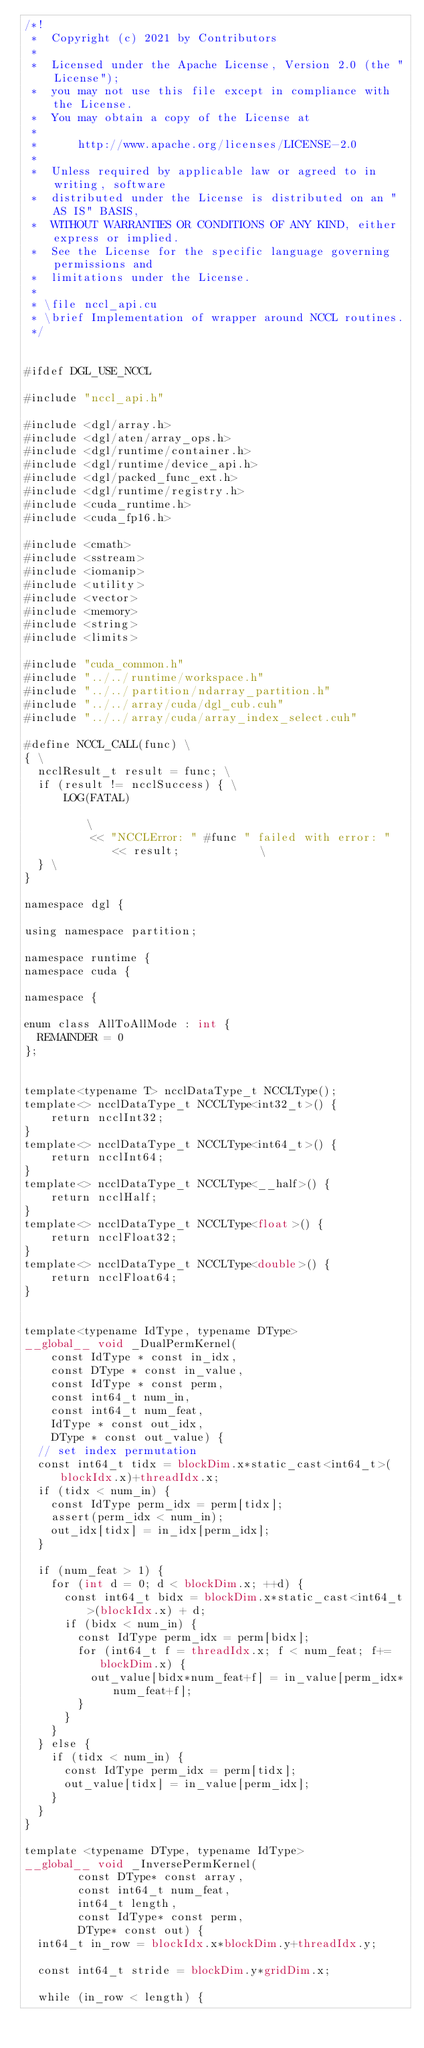Convert code to text. <code><loc_0><loc_0><loc_500><loc_500><_Cuda_>/*!
 *  Copyright (c) 2021 by Contributors
 *
 *  Licensed under the Apache License, Version 2.0 (the "License");
 *  you may not use this file except in compliance with the License.
 *  You may obtain a copy of the License at
 *
 *      http://www.apache.org/licenses/LICENSE-2.0
 *
 *  Unless required by applicable law or agreed to in writing, software
 *  distributed under the License is distributed on an "AS IS" BASIS,
 *  WITHOUT WARRANTIES OR CONDITIONS OF ANY KIND, either express or implied.
 *  See the License for the specific language governing permissions and
 *  limitations under the License.
 *
 * \file nccl_api.cu
 * \brief Implementation of wrapper around NCCL routines.
 */


#ifdef DGL_USE_NCCL

#include "nccl_api.h"

#include <dgl/array.h>
#include <dgl/aten/array_ops.h>
#include <dgl/runtime/container.h>
#include <dgl/runtime/device_api.h>
#include <dgl/packed_func_ext.h>
#include <dgl/runtime/registry.h>
#include <cuda_runtime.h>
#include <cuda_fp16.h>

#include <cmath>
#include <sstream>
#include <iomanip>
#include <utility>
#include <vector>
#include <memory>
#include <string>
#include <limits>

#include "cuda_common.h"
#include "../../runtime/workspace.h"
#include "../../partition/ndarray_partition.h"
#include "../../array/cuda/dgl_cub.cuh"
#include "../../array/cuda/array_index_select.cuh"

#define NCCL_CALL(func) \
{ \
  ncclResult_t result = func; \
  if (result != ncclSuccess) { \
      LOG(FATAL)                                                        \
          << "NCCLError: " #func " failed with error: " << result;            \
  } \
}

namespace dgl {

using namespace partition;

namespace runtime {
namespace cuda {

namespace {

enum class AllToAllMode : int {
  REMAINDER = 0
};


template<typename T> ncclDataType_t NCCLType();
template<> ncclDataType_t NCCLType<int32_t>() {
    return ncclInt32;
}
template<> ncclDataType_t NCCLType<int64_t>() {
    return ncclInt64;
}
template<> ncclDataType_t NCCLType<__half>() {
    return ncclHalf;
}
template<> ncclDataType_t NCCLType<float>() {
    return ncclFloat32;
}
template<> ncclDataType_t NCCLType<double>() {
    return ncclFloat64;
}


template<typename IdType, typename DType>
__global__ void _DualPermKernel(
    const IdType * const in_idx,
    const DType * const in_value,
    const IdType * const perm,
    const int64_t num_in,
    const int64_t num_feat,
    IdType * const out_idx,
    DType * const out_value) {
  // set index permutation
  const int64_t tidx = blockDim.x*static_cast<int64_t>(blockIdx.x)+threadIdx.x;
  if (tidx < num_in) {
    const IdType perm_idx = perm[tidx];
    assert(perm_idx < num_in);
    out_idx[tidx] = in_idx[perm_idx];
  }

  if (num_feat > 1) {
    for (int d = 0; d < blockDim.x; ++d) {
      const int64_t bidx = blockDim.x*static_cast<int64_t>(blockIdx.x) + d;
      if (bidx < num_in) {
        const IdType perm_idx = perm[bidx];
        for (int64_t f = threadIdx.x; f < num_feat; f+=blockDim.x) {
          out_value[bidx*num_feat+f] = in_value[perm_idx*num_feat+f];
        }
      }
    }
  } else {
    if (tidx < num_in) {
      const IdType perm_idx = perm[tidx];
      out_value[tidx] = in_value[perm_idx];
    }
  }
}

template <typename DType, typename IdType>
__global__ void _InversePermKernel(
        const DType* const array,
        const int64_t num_feat,
        int64_t length,
        const IdType* const perm,
        DType* const out) {
  int64_t in_row = blockIdx.x*blockDim.y+threadIdx.y;

  const int64_t stride = blockDim.y*gridDim.x;

  while (in_row < length) {</code> 